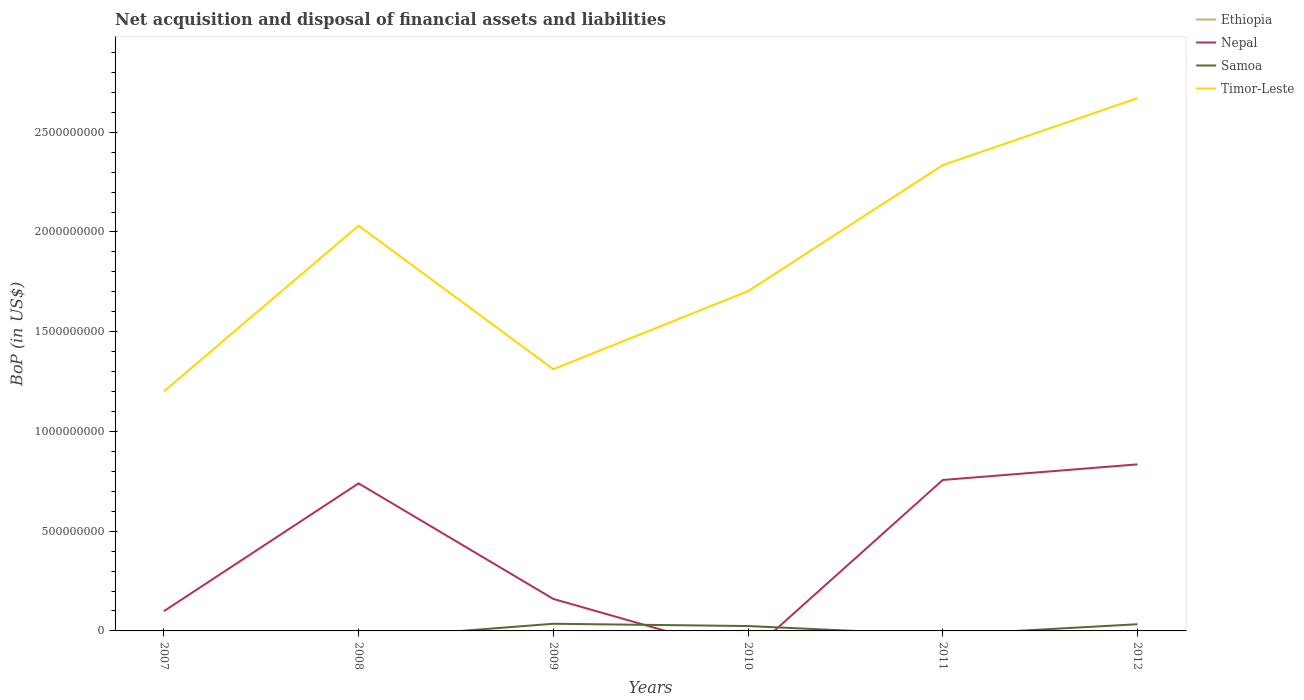How many different coloured lines are there?
Keep it short and to the point. 3. Does the line corresponding to Nepal intersect with the line corresponding to Timor-Leste?
Keep it short and to the point. No. Is the number of lines equal to the number of legend labels?
Make the answer very short. No. Across all years, what is the maximum Balance of Payments in Nepal?
Make the answer very short. 0. What is the total Balance of Payments in Timor-Leste in the graph?
Give a very brief answer. 7.20e+08. What is the difference between the highest and the second highest Balance of Payments in Nepal?
Make the answer very short. 8.35e+08. What is the difference between the highest and the lowest Balance of Payments in Timor-Leste?
Your answer should be compact. 3. How many years are there in the graph?
Make the answer very short. 6. Are the values on the major ticks of Y-axis written in scientific E-notation?
Your answer should be compact. No. Where does the legend appear in the graph?
Give a very brief answer. Top right. How are the legend labels stacked?
Offer a terse response. Vertical. What is the title of the graph?
Your response must be concise. Net acquisition and disposal of financial assets and liabilities. Does "Burkina Faso" appear as one of the legend labels in the graph?
Your answer should be very brief. No. What is the label or title of the Y-axis?
Ensure brevity in your answer.  BoP (in US$). What is the BoP (in US$) of Ethiopia in 2007?
Ensure brevity in your answer.  0. What is the BoP (in US$) of Nepal in 2007?
Provide a succinct answer. 9.88e+07. What is the BoP (in US$) in Timor-Leste in 2007?
Ensure brevity in your answer.  1.20e+09. What is the BoP (in US$) in Nepal in 2008?
Ensure brevity in your answer.  7.40e+08. What is the BoP (in US$) in Samoa in 2008?
Provide a short and direct response. 0. What is the BoP (in US$) of Timor-Leste in 2008?
Offer a very short reply. 2.03e+09. What is the BoP (in US$) in Nepal in 2009?
Give a very brief answer. 1.60e+08. What is the BoP (in US$) in Samoa in 2009?
Offer a very short reply. 3.59e+07. What is the BoP (in US$) in Timor-Leste in 2009?
Your answer should be compact. 1.31e+09. What is the BoP (in US$) in Ethiopia in 2010?
Ensure brevity in your answer.  0. What is the BoP (in US$) in Nepal in 2010?
Provide a succinct answer. 0. What is the BoP (in US$) of Samoa in 2010?
Your answer should be compact. 2.45e+07. What is the BoP (in US$) of Timor-Leste in 2010?
Ensure brevity in your answer.  1.70e+09. What is the BoP (in US$) in Nepal in 2011?
Make the answer very short. 7.57e+08. What is the BoP (in US$) in Samoa in 2011?
Your answer should be very brief. 0. What is the BoP (in US$) in Timor-Leste in 2011?
Offer a very short reply. 2.34e+09. What is the BoP (in US$) of Nepal in 2012?
Offer a terse response. 8.35e+08. What is the BoP (in US$) in Samoa in 2012?
Keep it short and to the point. 3.36e+07. What is the BoP (in US$) of Timor-Leste in 2012?
Keep it short and to the point. 2.67e+09. Across all years, what is the maximum BoP (in US$) in Nepal?
Offer a terse response. 8.35e+08. Across all years, what is the maximum BoP (in US$) in Samoa?
Provide a succinct answer. 3.59e+07. Across all years, what is the maximum BoP (in US$) in Timor-Leste?
Your response must be concise. 2.67e+09. Across all years, what is the minimum BoP (in US$) in Timor-Leste?
Make the answer very short. 1.20e+09. What is the total BoP (in US$) of Ethiopia in the graph?
Offer a very short reply. 0. What is the total BoP (in US$) of Nepal in the graph?
Give a very brief answer. 2.59e+09. What is the total BoP (in US$) of Samoa in the graph?
Offer a terse response. 9.40e+07. What is the total BoP (in US$) in Timor-Leste in the graph?
Ensure brevity in your answer.  1.13e+1. What is the difference between the BoP (in US$) of Nepal in 2007 and that in 2008?
Give a very brief answer. -6.41e+08. What is the difference between the BoP (in US$) of Timor-Leste in 2007 and that in 2008?
Your response must be concise. -8.31e+08. What is the difference between the BoP (in US$) in Nepal in 2007 and that in 2009?
Provide a short and direct response. -6.17e+07. What is the difference between the BoP (in US$) of Timor-Leste in 2007 and that in 2009?
Keep it short and to the point. -1.12e+08. What is the difference between the BoP (in US$) in Timor-Leste in 2007 and that in 2010?
Give a very brief answer. -5.03e+08. What is the difference between the BoP (in US$) in Nepal in 2007 and that in 2011?
Offer a terse response. -6.58e+08. What is the difference between the BoP (in US$) in Timor-Leste in 2007 and that in 2011?
Your answer should be very brief. -1.13e+09. What is the difference between the BoP (in US$) of Nepal in 2007 and that in 2012?
Provide a succinct answer. -7.36e+08. What is the difference between the BoP (in US$) in Timor-Leste in 2007 and that in 2012?
Provide a succinct answer. -1.47e+09. What is the difference between the BoP (in US$) of Nepal in 2008 and that in 2009?
Provide a short and direct response. 5.79e+08. What is the difference between the BoP (in US$) of Timor-Leste in 2008 and that in 2009?
Your answer should be very brief. 7.20e+08. What is the difference between the BoP (in US$) in Timor-Leste in 2008 and that in 2010?
Your response must be concise. 3.29e+08. What is the difference between the BoP (in US$) of Nepal in 2008 and that in 2011?
Provide a succinct answer. -1.71e+07. What is the difference between the BoP (in US$) of Timor-Leste in 2008 and that in 2011?
Provide a short and direct response. -3.04e+08. What is the difference between the BoP (in US$) of Nepal in 2008 and that in 2012?
Make the answer very short. -9.53e+07. What is the difference between the BoP (in US$) of Timor-Leste in 2008 and that in 2012?
Offer a very short reply. -6.39e+08. What is the difference between the BoP (in US$) in Samoa in 2009 and that in 2010?
Provide a short and direct response. 1.14e+07. What is the difference between the BoP (in US$) of Timor-Leste in 2009 and that in 2010?
Give a very brief answer. -3.91e+08. What is the difference between the BoP (in US$) of Nepal in 2009 and that in 2011?
Provide a short and direct response. -5.96e+08. What is the difference between the BoP (in US$) in Timor-Leste in 2009 and that in 2011?
Your answer should be very brief. -1.02e+09. What is the difference between the BoP (in US$) of Nepal in 2009 and that in 2012?
Your answer should be compact. -6.75e+08. What is the difference between the BoP (in US$) of Samoa in 2009 and that in 2012?
Make the answer very short. 2.33e+06. What is the difference between the BoP (in US$) of Timor-Leste in 2009 and that in 2012?
Make the answer very short. -1.36e+09. What is the difference between the BoP (in US$) of Timor-Leste in 2010 and that in 2011?
Make the answer very short. -6.32e+08. What is the difference between the BoP (in US$) in Samoa in 2010 and that in 2012?
Give a very brief answer. -9.05e+06. What is the difference between the BoP (in US$) in Timor-Leste in 2010 and that in 2012?
Your answer should be very brief. -9.68e+08. What is the difference between the BoP (in US$) in Nepal in 2011 and that in 2012?
Your answer should be very brief. -7.82e+07. What is the difference between the BoP (in US$) of Timor-Leste in 2011 and that in 2012?
Your response must be concise. -3.36e+08. What is the difference between the BoP (in US$) in Nepal in 2007 and the BoP (in US$) in Timor-Leste in 2008?
Ensure brevity in your answer.  -1.93e+09. What is the difference between the BoP (in US$) of Nepal in 2007 and the BoP (in US$) of Samoa in 2009?
Your answer should be compact. 6.29e+07. What is the difference between the BoP (in US$) of Nepal in 2007 and the BoP (in US$) of Timor-Leste in 2009?
Provide a short and direct response. -1.21e+09. What is the difference between the BoP (in US$) of Nepal in 2007 and the BoP (in US$) of Samoa in 2010?
Offer a very short reply. 7.43e+07. What is the difference between the BoP (in US$) in Nepal in 2007 and the BoP (in US$) in Timor-Leste in 2010?
Provide a succinct answer. -1.60e+09. What is the difference between the BoP (in US$) in Nepal in 2007 and the BoP (in US$) in Timor-Leste in 2011?
Your response must be concise. -2.24e+09. What is the difference between the BoP (in US$) in Nepal in 2007 and the BoP (in US$) in Samoa in 2012?
Keep it short and to the point. 6.52e+07. What is the difference between the BoP (in US$) of Nepal in 2007 and the BoP (in US$) of Timor-Leste in 2012?
Your answer should be compact. -2.57e+09. What is the difference between the BoP (in US$) of Nepal in 2008 and the BoP (in US$) of Samoa in 2009?
Keep it short and to the point. 7.04e+08. What is the difference between the BoP (in US$) in Nepal in 2008 and the BoP (in US$) in Timor-Leste in 2009?
Your answer should be very brief. -5.72e+08. What is the difference between the BoP (in US$) in Nepal in 2008 and the BoP (in US$) in Samoa in 2010?
Your answer should be very brief. 7.15e+08. What is the difference between the BoP (in US$) in Nepal in 2008 and the BoP (in US$) in Timor-Leste in 2010?
Offer a very short reply. -9.63e+08. What is the difference between the BoP (in US$) in Nepal in 2008 and the BoP (in US$) in Timor-Leste in 2011?
Your answer should be very brief. -1.60e+09. What is the difference between the BoP (in US$) in Nepal in 2008 and the BoP (in US$) in Samoa in 2012?
Make the answer very short. 7.06e+08. What is the difference between the BoP (in US$) in Nepal in 2008 and the BoP (in US$) in Timor-Leste in 2012?
Offer a very short reply. -1.93e+09. What is the difference between the BoP (in US$) of Nepal in 2009 and the BoP (in US$) of Samoa in 2010?
Your response must be concise. 1.36e+08. What is the difference between the BoP (in US$) of Nepal in 2009 and the BoP (in US$) of Timor-Leste in 2010?
Your response must be concise. -1.54e+09. What is the difference between the BoP (in US$) of Samoa in 2009 and the BoP (in US$) of Timor-Leste in 2010?
Provide a succinct answer. -1.67e+09. What is the difference between the BoP (in US$) of Nepal in 2009 and the BoP (in US$) of Timor-Leste in 2011?
Make the answer very short. -2.17e+09. What is the difference between the BoP (in US$) of Samoa in 2009 and the BoP (in US$) of Timor-Leste in 2011?
Your answer should be compact. -2.30e+09. What is the difference between the BoP (in US$) of Nepal in 2009 and the BoP (in US$) of Samoa in 2012?
Provide a short and direct response. 1.27e+08. What is the difference between the BoP (in US$) of Nepal in 2009 and the BoP (in US$) of Timor-Leste in 2012?
Provide a succinct answer. -2.51e+09. What is the difference between the BoP (in US$) of Samoa in 2009 and the BoP (in US$) of Timor-Leste in 2012?
Offer a very short reply. -2.64e+09. What is the difference between the BoP (in US$) of Samoa in 2010 and the BoP (in US$) of Timor-Leste in 2011?
Keep it short and to the point. -2.31e+09. What is the difference between the BoP (in US$) of Samoa in 2010 and the BoP (in US$) of Timor-Leste in 2012?
Your response must be concise. -2.65e+09. What is the difference between the BoP (in US$) of Nepal in 2011 and the BoP (in US$) of Samoa in 2012?
Give a very brief answer. 7.23e+08. What is the difference between the BoP (in US$) in Nepal in 2011 and the BoP (in US$) in Timor-Leste in 2012?
Give a very brief answer. -1.91e+09. What is the average BoP (in US$) of Ethiopia per year?
Your answer should be compact. 0. What is the average BoP (in US$) in Nepal per year?
Provide a short and direct response. 4.32e+08. What is the average BoP (in US$) in Samoa per year?
Offer a very short reply. 1.57e+07. What is the average BoP (in US$) of Timor-Leste per year?
Provide a succinct answer. 1.88e+09. In the year 2007, what is the difference between the BoP (in US$) of Nepal and BoP (in US$) of Timor-Leste?
Your answer should be compact. -1.10e+09. In the year 2008, what is the difference between the BoP (in US$) of Nepal and BoP (in US$) of Timor-Leste?
Your response must be concise. -1.29e+09. In the year 2009, what is the difference between the BoP (in US$) in Nepal and BoP (in US$) in Samoa?
Offer a terse response. 1.25e+08. In the year 2009, what is the difference between the BoP (in US$) in Nepal and BoP (in US$) in Timor-Leste?
Offer a very short reply. -1.15e+09. In the year 2009, what is the difference between the BoP (in US$) of Samoa and BoP (in US$) of Timor-Leste?
Your answer should be compact. -1.28e+09. In the year 2010, what is the difference between the BoP (in US$) of Samoa and BoP (in US$) of Timor-Leste?
Offer a very short reply. -1.68e+09. In the year 2011, what is the difference between the BoP (in US$) in Nepal and BoP (in US$) in Timor-Leste?
Your response must be concise. -1.58e+09. In the year 2012, what is the difference between the BoP (in US$) in Nepal and BoP (in US$) in Samoa?
Ensure brevity in your answer.  8.01e+08. In the year 2012, what is the difference between the BoP (in US$) in Nepal and BoP (in US$) in Timor-Leste?
Provide a succinct answer. -1.84e+09. In the year 2012, what is the difference between the BoP (in US$) in Samoa and BoP (in US$) in Timor-Leste?
Provide a short and direct response. -2.64e+09. What is the ratio of the BoP (in US$) in Nepal in 2007 to that in 2008?
Make the answer very short. 0.13. What is the ratio of the BoP (in US$) of Timor-Leste in 2007 to that in 2008?
Ensure brevity in your answer.  0.59. What is the ratio of the BoP (in US$) of Nepal in 2007 to that in 2009?
Offer a very short reply. 0.62. What is the ratio of the BoP (in US$) in Timor-Leste in 2007 to that in 2009?
Your answer should be compact. 0.91. What is the ratio of the BoP (in US$) of Timor-Leste in 2007 to that in 2010?
Offer a terse response. 0.7. What is the ratio of the BoP (in US$) in Nepal in 2007 to that in 2011?
Make the answer very short. 0.13. What is the ratio of the BoP (in US$) of Timor-Leste in 2007 to that in 2011?
Keep it short and to the point. 0.51. What is the ratio of the BoP (in US$) in Nepal in 2007 to that in 2012?
Give a very brief answer. 0.12. What is the ratio of the BoP (in US$) of Timor-Leste in 2007 to that in 2012?
Provide a succinct answer. 0.45. What is the ratio of the BoP (in US$) of Nepal in 2008 to that in 2009?
Your response must be concise. 4.61. What is the ratio of the BoP (in US$) of Timor-Leste in 2008 to that in 2009?
Offer a very short reply. 1.55. What is the ratio of the BoP (in US$) of Timor-Leste in 2008 to that in 2010?
Ensure brevity in your answer.  1.19. What is the ratio of the BoP (in US$) of Nepal in 2008 to that in 2011?
Make the answer very short. 0.98. What is the ratio of the BoP (in US$) of Timor-Leste in 2008 to that in 2011?
Provide a succinct answer. 0.87. What is the ratio of the BoP (in US$) in Nepal in 2008 to that in 2012?
Keep it short and to the point. 0.89. What is the ratio of the BoP (in US$) of Timor-Leste in 2008 to that in 2012?
Your answer should be compact. 0.76. What is the ratio of the BoP (in US$) of Samoa in 2009 to that in 2010?
Make the answer very short. 1.46. What is the ratio of the BoP (in US$) of Timor-Leste in 2009 to that in 2010?
Provide a succinct answer. 0.77. What is the ratio of the BoP (in US$) of Nepal in 2009 to that in 2011?
Provide a short and direct response. 0.21. What is the ratio of the BoP (in US$) of Timor-Leste in 2009 to that in 2011?
Provide a succinct answer. 0.56. What is the ratio of the BoP (in US$) of Nepal in 2009 to that in 2012?
Provide a succinct answer. 0.19. What is the ratio of the BoP (in US$) in Samoa in 2009 to that in 2012?
Offer a very short reply. 1.07. What is the ratio of the BoP (in US$) of Timor-Leste in 2009 to that in 2012?
Keep it short and to the point. 0.49. What is the ratio of the BoP (in US$) of Timor-Leste in 2010 to that in 2011?
Ensure brevity in your answer.  0.73. What is the ratio of the BoP (in US$) in Samoa in 2010 to that in 2012?
Ensure brevity in your answer.  0.73. What is the ratio of the BoP (in US$) in Timor-Leste in 2010 to that in 2012?
Your response must be concise. 0.64. What is the ratio of the BoP (in US$) in Nepal in 2011 to that in 2012?
Offer a very short reply. 0.91. What is the ratio of the BoP (in US$) in Timor-Leste in 2011 to that in 2012?
Ensure brevity in your answer.  0.87. What is the difference between the highest and the second highest BoP (in US$) of Nepal?
Ensure brevity in your answer.  7.82e+07. What is the difference between the highest and the second highest BoP (in US$) of Samoa?
Make the answer very short. 2.33e+06. What is the difference between the highest and the second highest BoP (in US$) in Timor-Leste?
Provide a short and direct response. 3.36e+08. What is the difference between the highest and the lowest BoP (in US$) of Nepal?
Your answer should be compact. 8.35e+08. What is the difference between the highest and the lowest BoP (in US$) in Samoa?
Ensure brevity in your answer.  3.59e+07. What is the difference between the highest and the lowest BoP (in US$) in Timor-Leste?
Ensure brevity in your answer.  1.47e+09. 